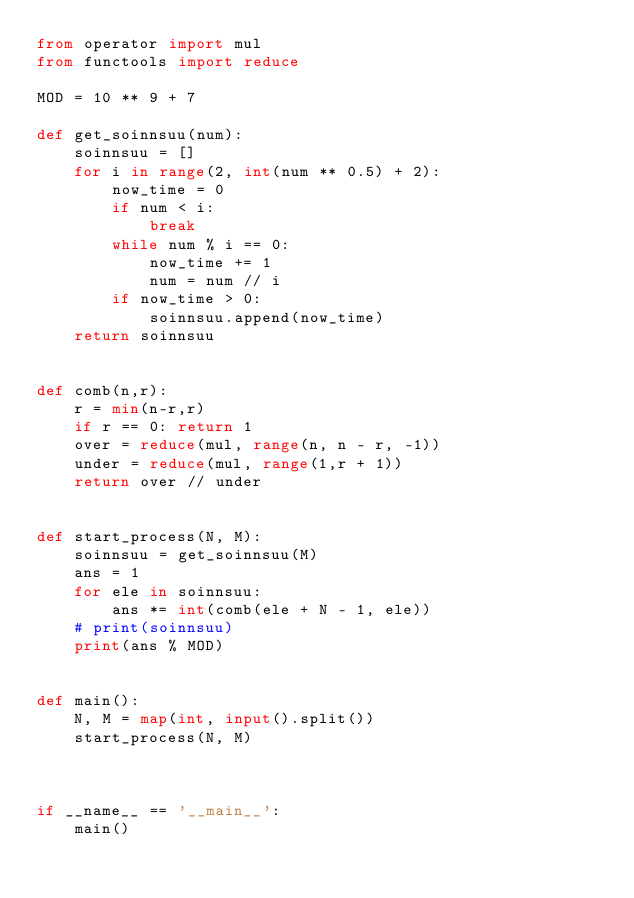<code> <loc_0><loc_0><loc_500><loc_500><_Python_>from operator import mul
from functools import reduce

MOD = 10 ** 9 + 7

def get_soinnsuu(num):
    soinnsuu = []
    for i in range(2, int(num ** 0.5) + 2):
        now_time = 0
        if num < i:
            break
        while num % i == 0:
            now_time += 1
            num = num // i
        if now_time > 0:
            soinnsuu.append(now_time)
    return soinnsuu


def comb(n,r):
    r = min(n-r,r)
    if r == 0: return 1
    over = reduce(mul, range(n, n - r, -1))
    under = reduce(mul, range(1,r + 1))
    return over // under


def start_process(N, M):
    soinnsuu = get_soinnsuu(M)
    ans = 1
    for ele in soinnsuu:
        ans *= int(comb(ele + N - 1, ele))
    # print(soinnsuu)
    print(ans % MOD)


def main():
    N, M = map(int, input().split())
    start_process(N, M)



if __name__ == '__main__':
    main()
</code> 